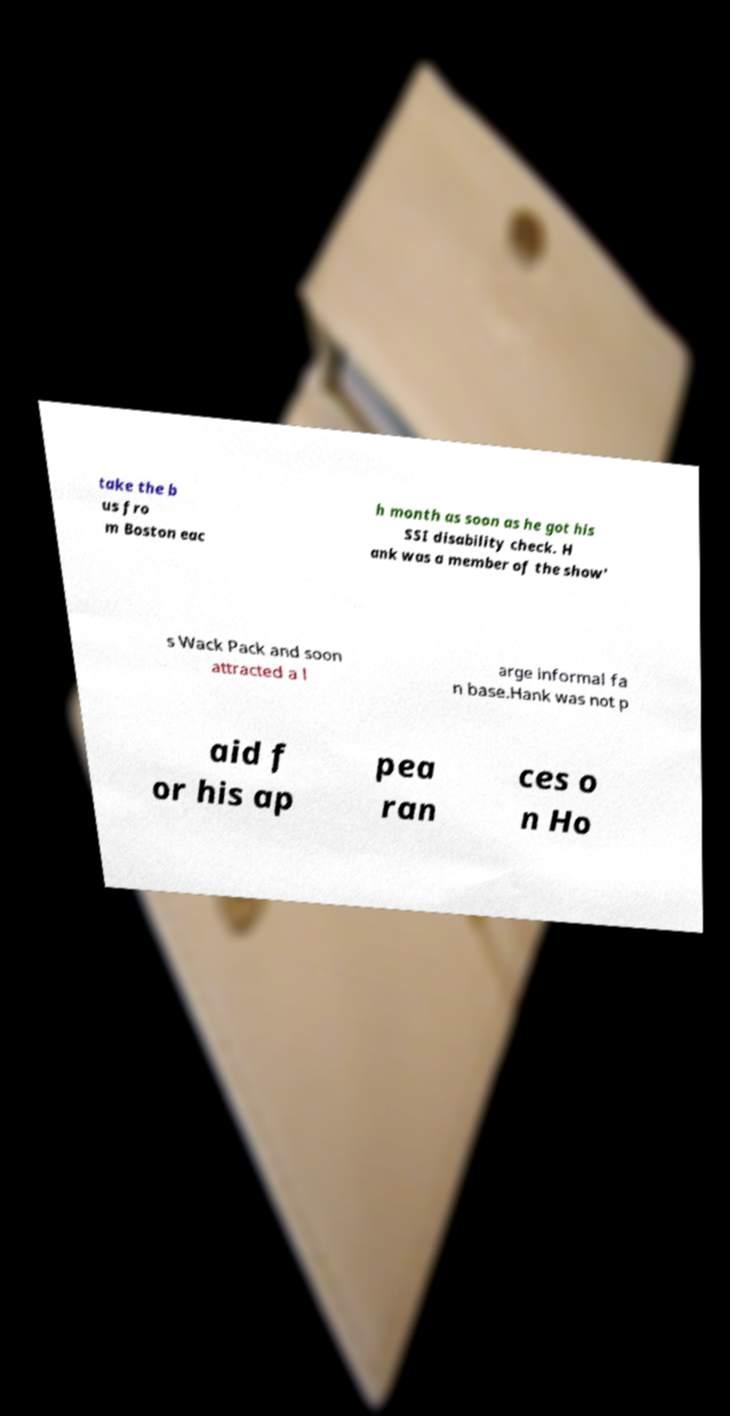Please identify and transcribe the text found in this image. take the b us fro m Boston eac h month as soon as he got his SSI disability check. H ank was a member of the show' s Wack Pack and soon attracted a l arge informal fa n base.Hank was not p aid f or his ap pea ran ces o n Ho 